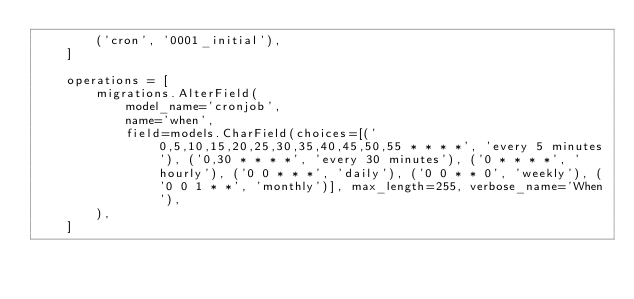<code> <loc_0><loc_0><loc_500><loc_500><_Python_>        ('cron', '0001_initial'),
    ]

    operations = [
        migrations.AlterField(
            model_name='cronjob',
            name='when',
            field=models.CharField(choices=[('0,5,10,15,20,25,30,35,40,45,50,55 * * * *', 'every 5 minutes'), ('0,30 * * * *', 'every 30 minutes'), ('0 * * * *', 'hourly'), ('0 0 * * *', 'daily'), ('0 0 * * 0', 'weekly'), ('0 0 1 * *', 'monthly')], max_length=255, verbose_name='When'),
        ),
    ]
</code> 